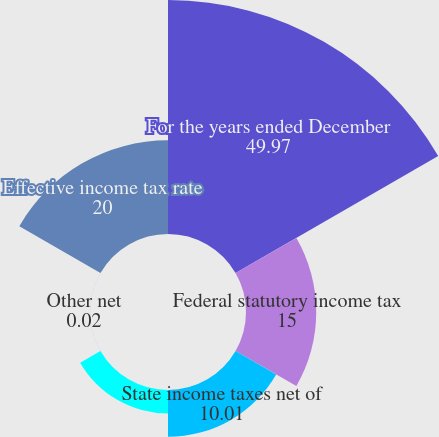<chart> <loc_0><loc_0><loc_500><loc_500><pie_chart><fcel>For the years ended December<fcel>Federal statutory income tax<fcel>State income taxes net of<fcel>Qualified production income<fcel>Other net<fcel>Effective income tax rate<nl><fcel>49.97%<fcel>15.0%<fcel>10.01%<fcel>5.01%<fcel>0.02%<fcel>20.0%<nl></chart> 